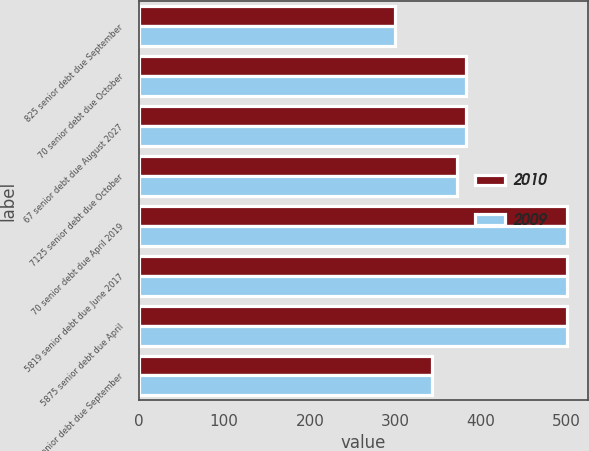Convert chart. <chart><loc_0><loc_0><loc_500><loc_500><stacked_bar_chart><ecel><fcel>825 senior debt due September<fcel>70 senior debt due October<fcel>67 senior debt due August 2027<fcel>7125 senior debt due October<fcel>70 senior debt due April 2019<fcel>5819 senior debt due June 2017<fcel>5875 senior debt due April<fcel>675 senior debt due September<nl><fcel>2010<fcel>300<fcel>382.2<fcel>382.2<fcel>372.4<fcel>500<fcel>500<fcel>500<fcel>342.7<nl><fcel>2009<fcel>300<fcel>382.2<fcel>382.2<fcel>372.4<fcel>500<fcel>500<fcel>500<fcel>342.7<nl></chart> 